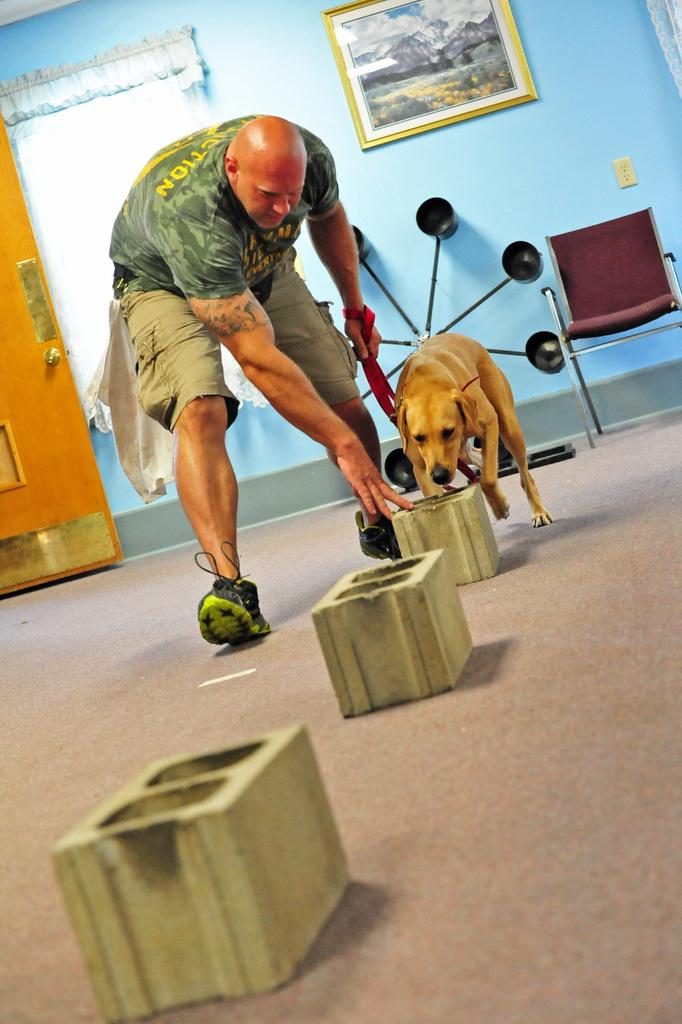What is present in the image? There is a man and a dog in the image. Can you describe the man in the image? The facts provided do not give any specific details about the man's appearance or actions. Can you describe the dog in the image? The facts provided do not give any specific details about the dog's appearance or actions. What is the man arguing about with the dog in the image? There is no argument present in the image, as it only features a man and a dog without any indication of conflict or disagreement. 